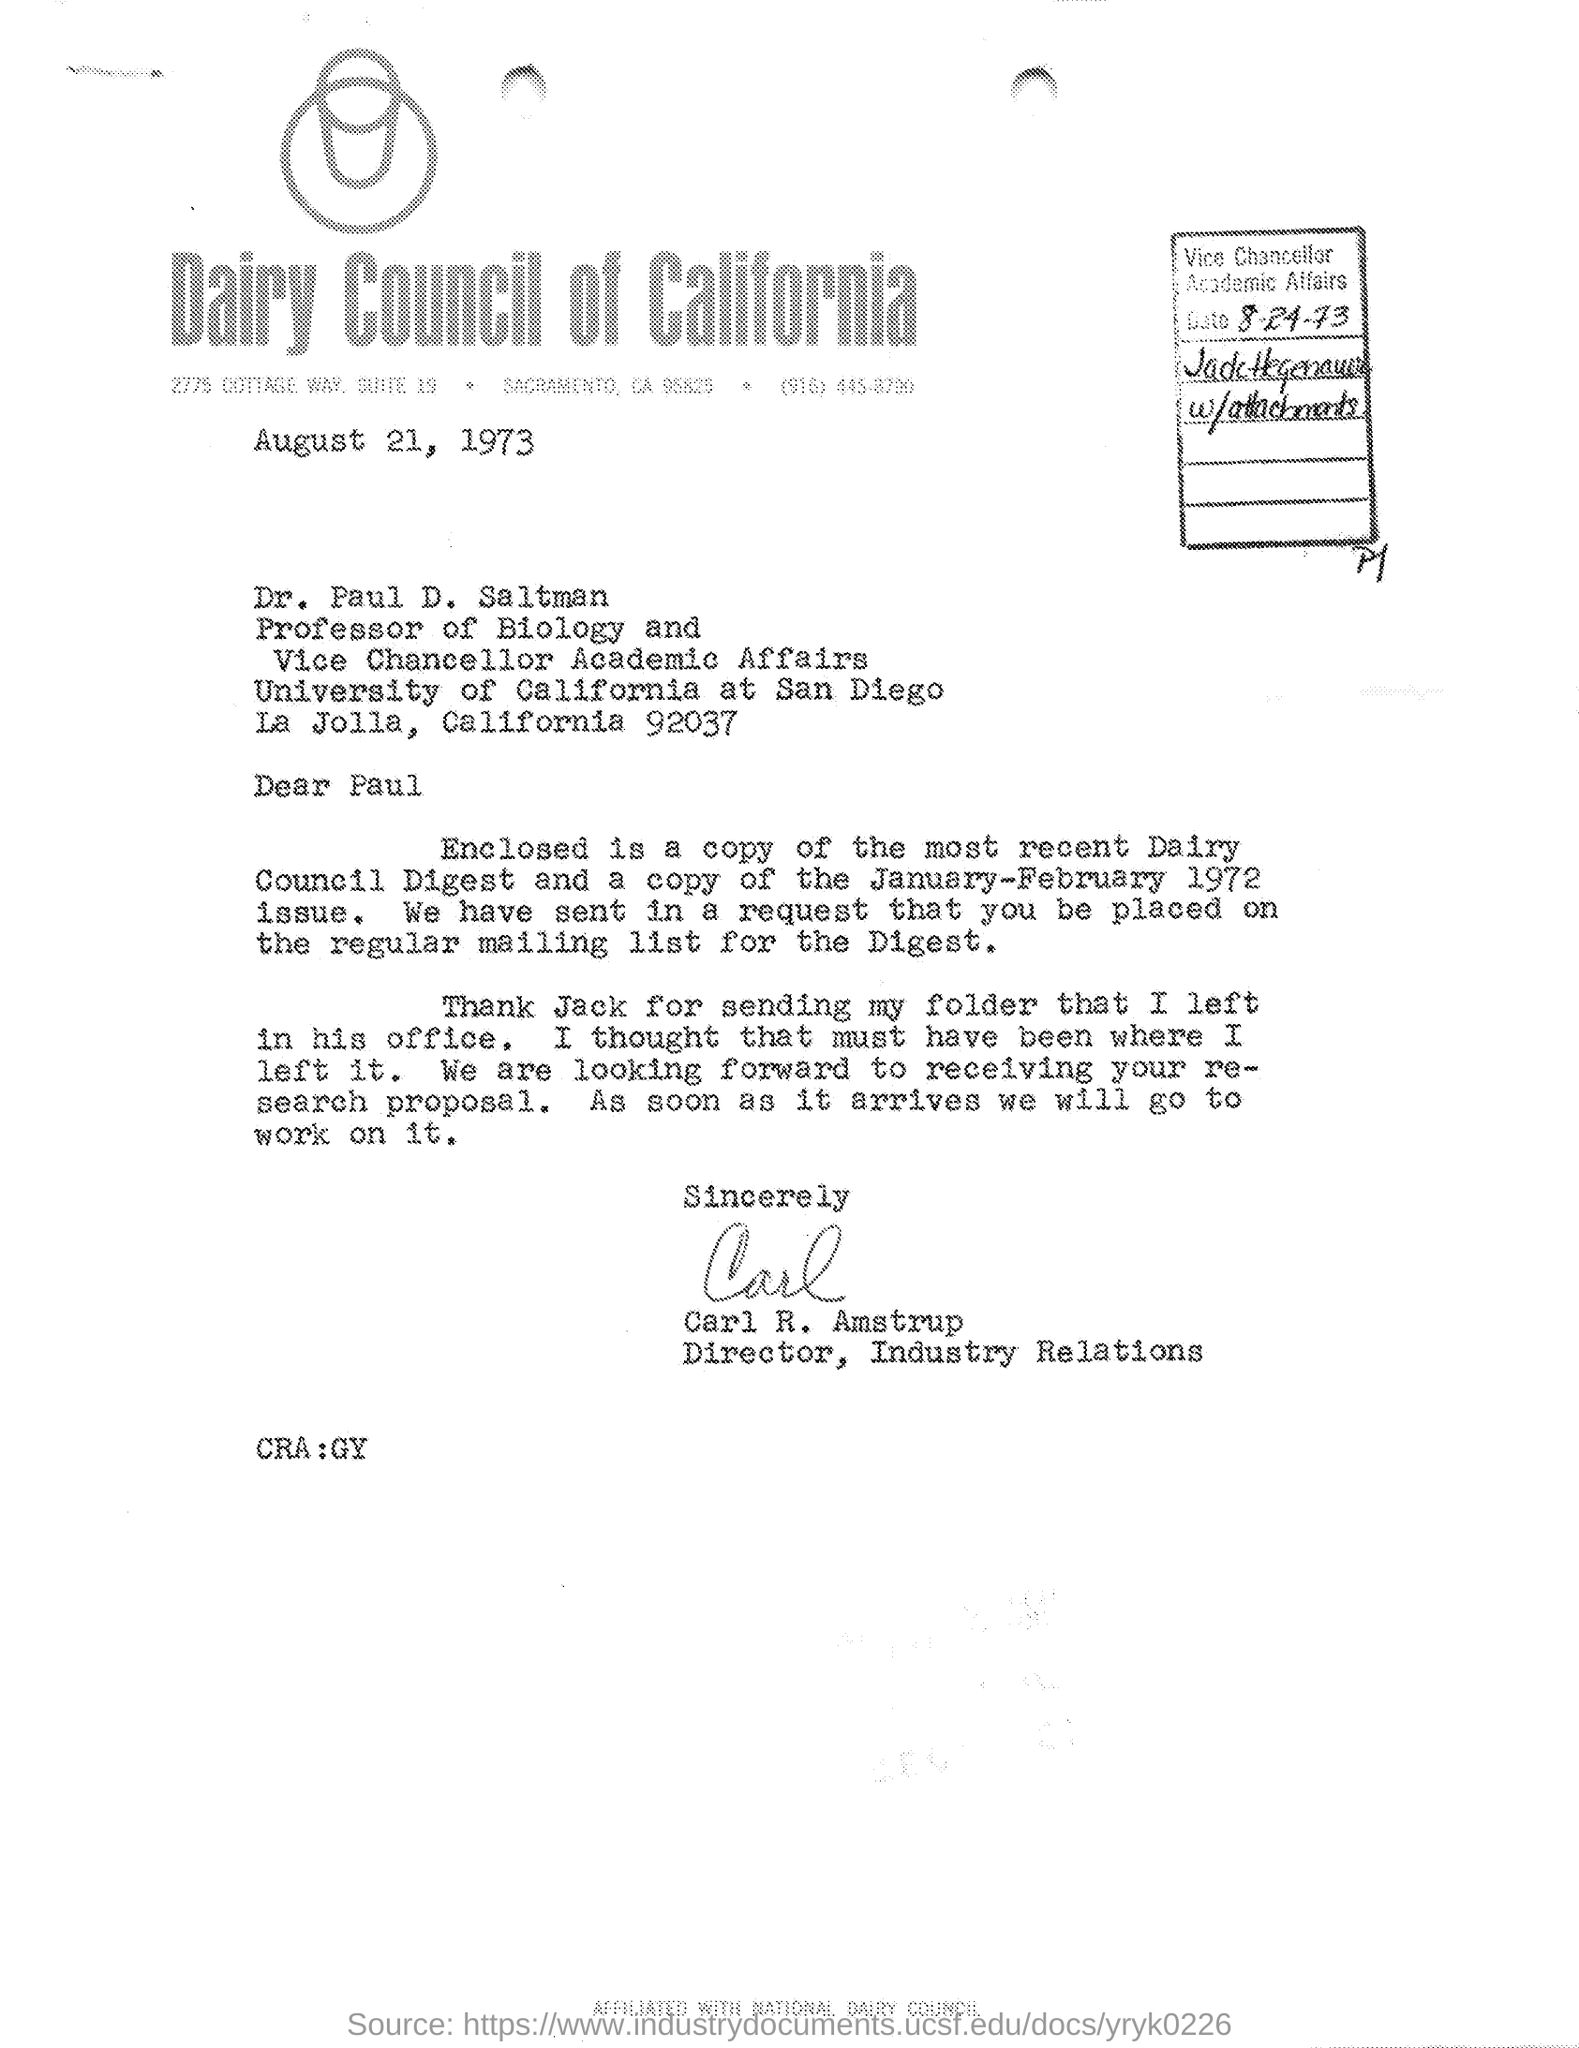Point out several critical features in this image. Dr. Paul D. Saltman is a Professor of Biology and the Vice Chancellor of Academic Affairs. On August 21, 1973, this letter was written. Carl R. Amstrup is designated as the Director of Industry Relations in the given letter. The sign at the end of the letter was that of Carl R. Amstrup. 